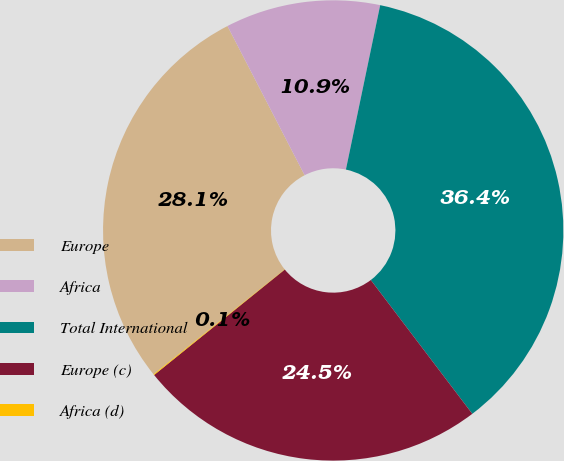Convert chart to OTSL. <chart><loc_0><loc_0><loc_500><loc_500><pie_chart><fcel>Europe<fcel>Africa<fcel>Total International<fcel>Europe (c)<fcel>Africa (d)<nl><fcel>28.15%<fcel>10.87%<fcel>36.4%<fcel>24.52%<fcel>0.06%<nl></chart> 